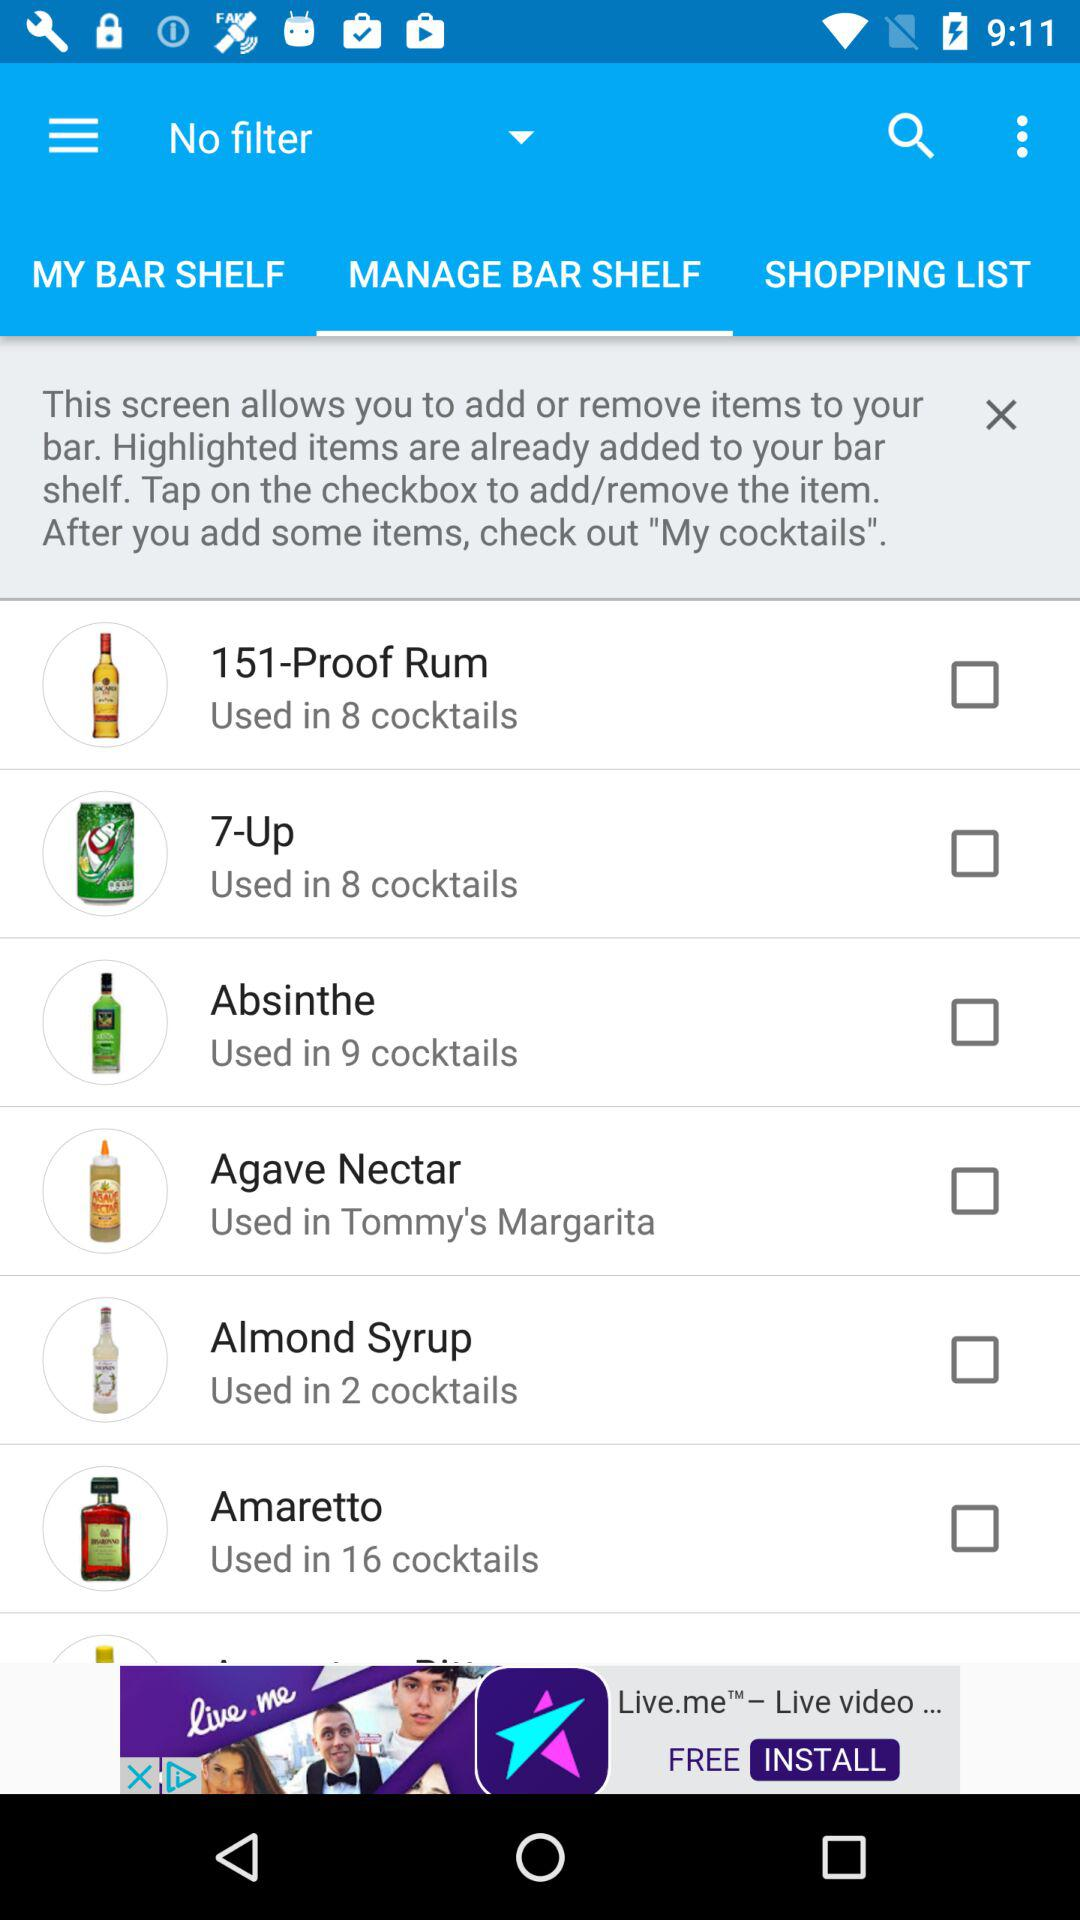How many "Almond Syrup" based drinks are there? There are 2 drinks based on "Almond Syrup". 